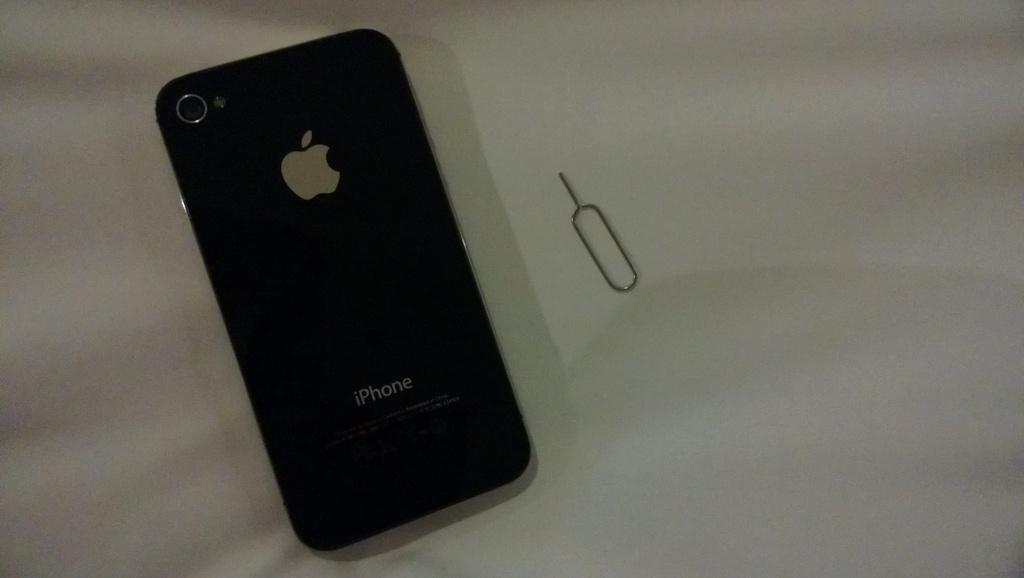<image>
Offer a succinct explanation of the picture presented. A black iPhone sits on a white background. 